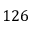Convert formula to latex. <formula><loc_0><loc_0><loc_500><loc_500>1 2 6</formula> 